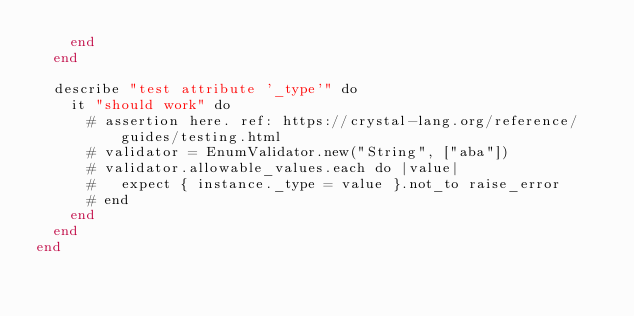<code> <loc_0><loc_0><loc_500><loc_500><_Crystal_>    end
  end

  describe "test attribute '_type'" do
    it "should work" do
      # assertion here. ref: https://crystal-lang.org/reference/guides/testing.html
      # validator = EnumValidator.new("String", ["aba"])
      # validator.allowable_values.each do |value|
      #   expect { instance._type = value }.not_to raise_error
      # end
    end
  end
end
</code> 